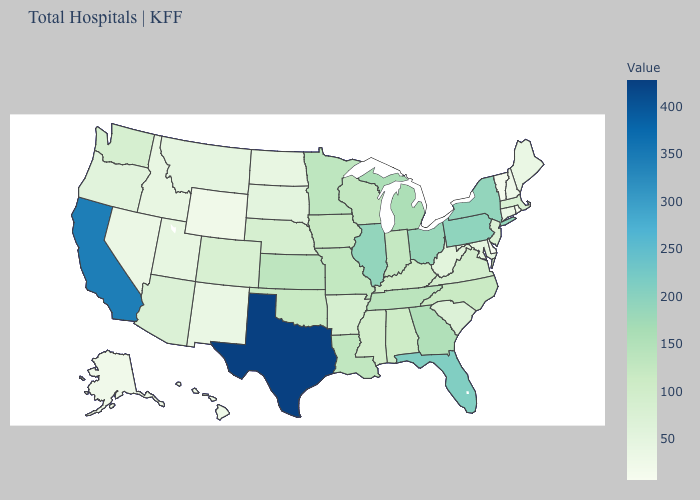Does Delaware have the lowest value in the USA?
Answer briefly. Yes. Which states hav the highest value in the West?
Be succinct. California. Does Illinois have a higher value than Massachusetts?
Write a very short answer. Yes. Does Texas have the highest value in the South?
Concise answer only. Yes. 